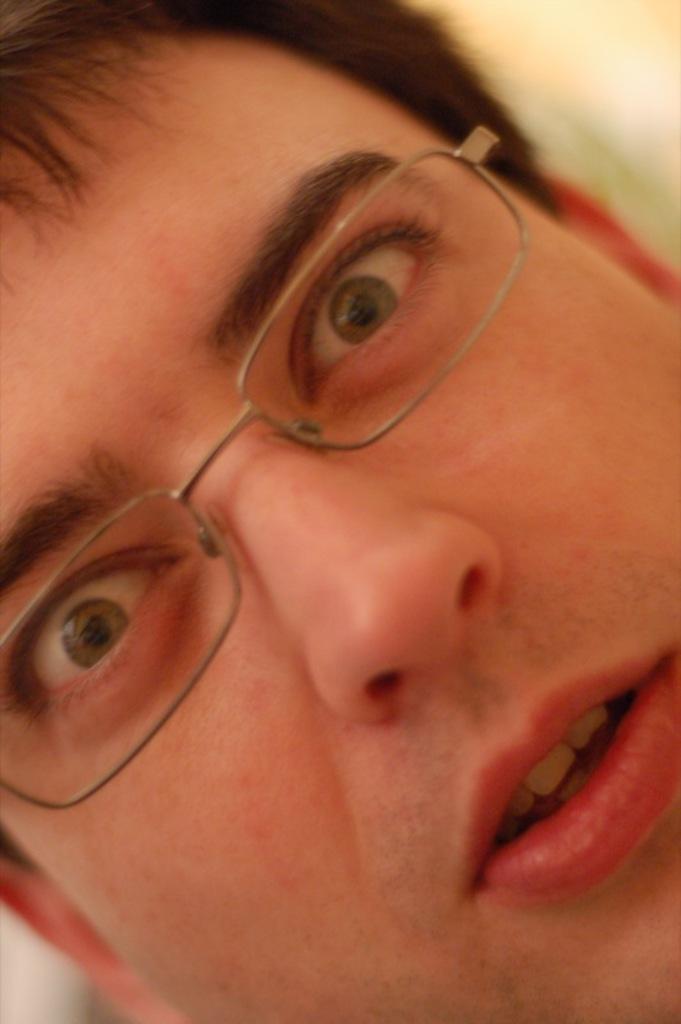Please provide a concise description of this image. In the picture I can the close view of a person wearing spectacles. The background of the image is blurred. 